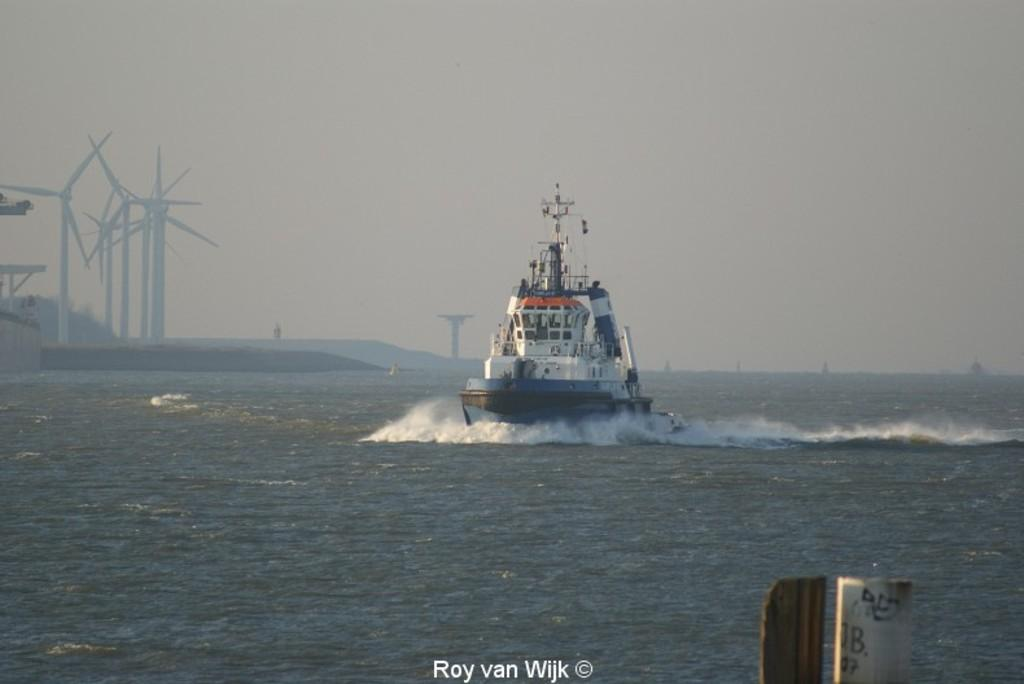What is the main subject of the image? There is a ship in the water in the image. What can be seen on the left side of the image? There are windmills on the left side of the image. What type of environment is depicted in the image? The image features water, which suggests a coastal or marine setting. What is written at the bottom of the image? There is text at the bottom of the image. What is the weather like in the image? The sky is cloudy in the image. How many balloons are floating in the wilderness in the image? There are no balloons or wilderness present in the image. What type of pump is used to inflate the ship in the image? There is no pump visible in the image, and the ship is not inflated; it is a solid structure. 